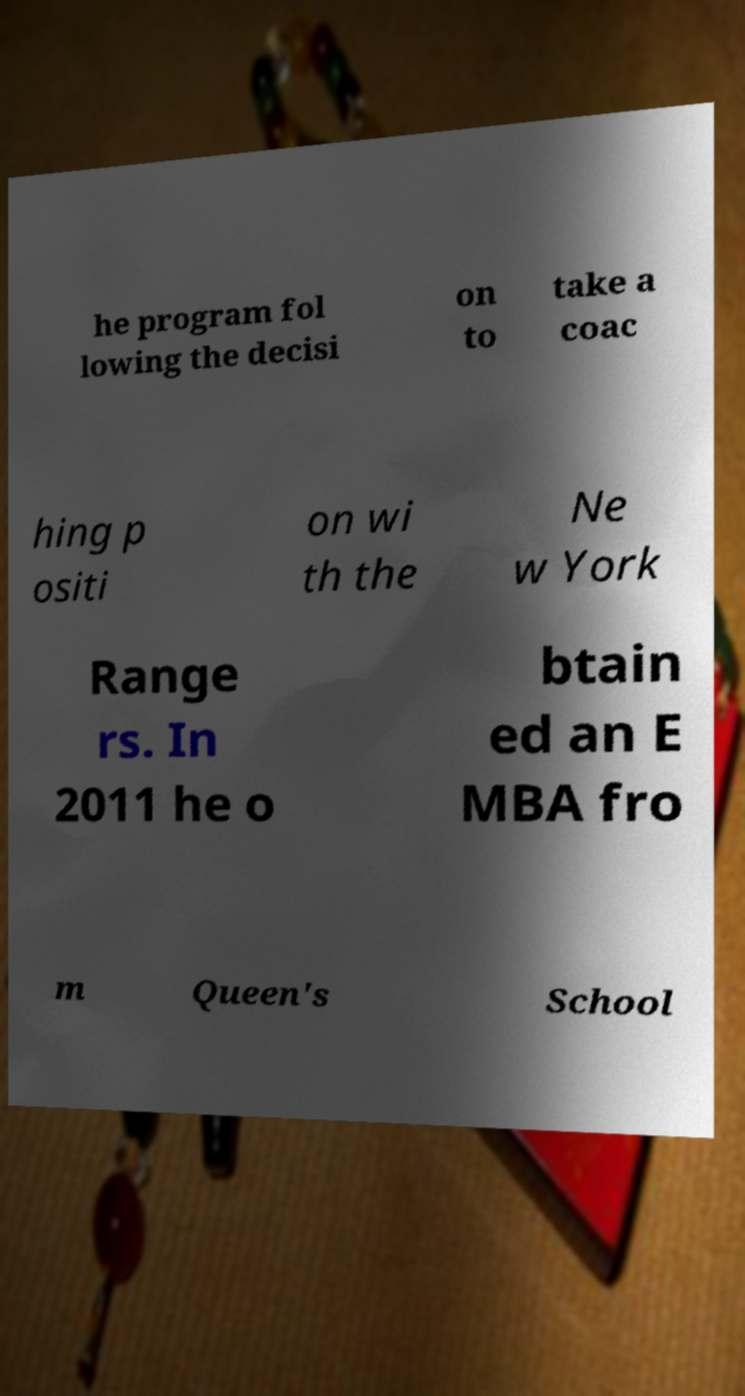Please identify and transcribe the text found in this image. he program fol lowing the decisi on to take a coac hing p ositi on wi th the Ne w York Range rs. In 2011 he o btain ed an E MBA fro m Queen's School 